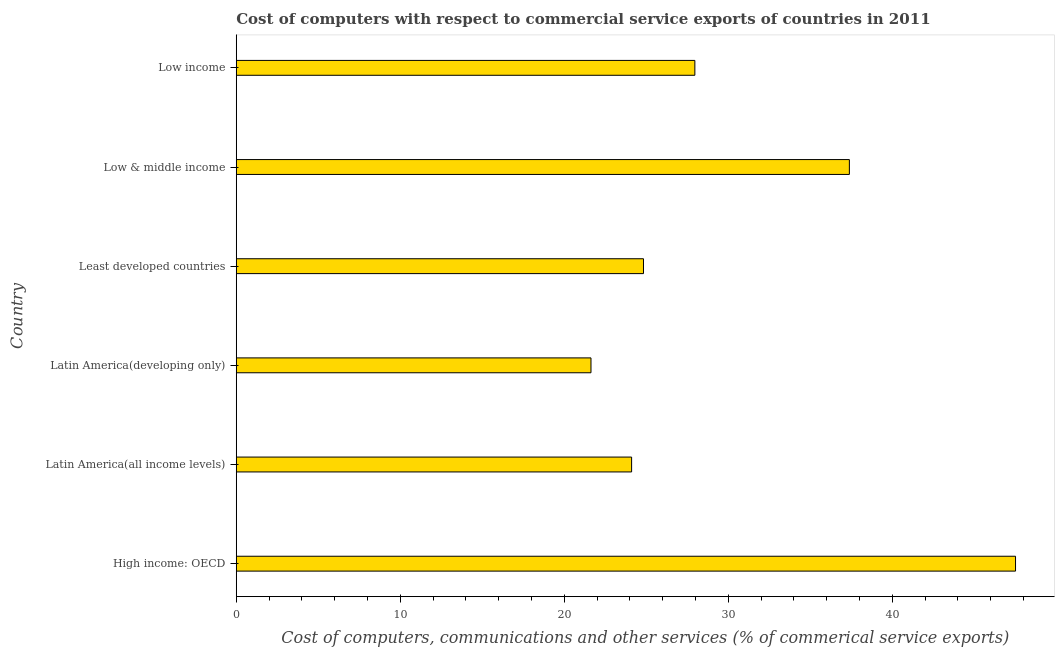What is the title of the graph?
Offer a terse response. Cost of computers with respect to commercial service exports of countries in 2011. What is the label or title of the X-axis?
Provide a short and direct response. Cost of computers, communications and other services (% of commerical service exports). What is the label or title of the Y-axis?
Your response must be concise. Country. What is the  computer and other services in Latin America(developing only)?
Your answer should be compact. 21.63. Across all countries, what is the maximum  computer and other services?
Your response must be concise. 47.51. Across all countries, what is the minimum cost of communications?
Provide a succinct answer. 21.63. In which country was the cost of communications maximum?
Keep it short and to the point. High income: OECD. In which country was the  computer and other services minimum?
Make the answer very short. Latin America(developing only). What is the sum of the  computer and other services?
Provide a short and direct response. 183.4. What is the difference between the  computer and other services in Latin America(all income levels) and Low & middle income?
Ensure brevity in your answer.  -13.28. What is the average  computer and other services per country?
Your response must be concise. 30.57. What is the median cost of communications?
Your answer should be very brief. 26.39. What is the ratio of the  computer and other services in Least developed countries to that in Low income?
Provide a short and direct response. 0.89. What is the difference between the highest and the second highest  computer and other services?
Your answer should be very brief. 10.13. Is the sum of the cost of communications in Latin America(developing only) and Low & middle income greater than the maximum cost of communications across all countries?
Keep it short and to the point. Yes. What is the difference between the highest and the lowest  computer and other services?
Keep it short and to the point. 25.88. Are all the bars in the graph horizontal?
Provide a short and direct response. Yes. Are the values on the major ticks of X-axis written in scientific E-notation?
Ensure brevity in your answer.  No. What is the Cost of computers, communications and other services (% of commerical service exports) in High income: OECD?
Keep it short and to the point. 47.51. What is the Cost of computers, communications and other services (% of commerical service exports) of Latin America(all income levels)?
Your answer should be compact. 24.1. What is the Cost of computers, communications and other services (% of commerical service exports) of Latin America(developing only)?
Keep it short and to the point. 21.63. What is the Cost of computers, communications and other services (% of commerical service exports) in Least developed countries?
Your response must be concise. 24.83. What is the Cost of computers, communications and other services (% of commerical service exports) of Low & middle income?
Keep it short and to the point. 37.38. What is the Cost of computers, communications and other services (% of commerical service exports) in Low income?
Your response must be concise. 27.96. What is the difference between the Cost of computers, communications and other services (% of commerical service exports) in High income: OECD and Latin America(all income levels)?
Your answer should be very brief. 23.41. What is the difference between the Cost of computers, communications and other services (% of commerical service exports) in High income: OECD and Latin America(developing only)?
Make the answer very short. 25.88. What is the difference between the Cost of computers, communications and other services (% of commerical service exports) in High income: OECD and Least developed countries?
Your response must be concise. 22.68. What is the difference between the Cost of computers, communications and other services (% of commerical service exports) in High income: OECD and Low & middle income?
Your response must be concise. 10.13. What is the difference between the Cost of computers, communications and other services (% of commerical service exports) in High income: OECD and Low income?
Make the answer very short. 19.55. What is the difference between the Cost of computers, communications and other services (% of commerical service exports) in Latin America(all income levels) and Latin America(developing only)?
Your answer should be very brief. 2.48. What is the difference between the Cost of computers, communications and other services (% of commerical service exports) in Latin America(all income levels) and Least developed countries?
Give a very brief answer. -0.72. What is the difference between the Cost of computers, communications and other services (% of commerical service exports) in Latin America(all income levels) and Low & middle income?
Offer a terse response. -13.28. What is the difference between the Cost of computers, communications and other services (% of commerical service exports) in Latin America(all income levels) and Low income?
Offer a very short reply. -3.86. What is the difference between the Cost of computers, communications and other services (% of commerical service exports) in Latin America(developing only) and Least developed countries?
Provide a short and direct response. -3.2. What is the difference between the Cost of computers, communications and other services (% of commerical service exports) in Latin America(developing only) and Low & middle income?
Ensure brevity in your answer.  -15.75. What is the difference between the Cost of computers, communications and other services (% of commerical service exports) in Latin America(developing only) and Low income?
Offer a terse response. -6.33. What is the difference between the Cost of computers, communications and other services (% of commerical service exports) in Least developed countries and Low & middle income?
Provide a succinct answer. -12.55. What is the difference between the Cost of computers, communications and other services (% of commerical service exports) in Least developed countries and Low income?
Your answer should be very brief. -3.13. What is the difference between the Cost of computers, communications and other services (% of commerical service exports) in Low & middle income and Low income?
Offer a very short reply. 9.42. What is the ratio of the Cost of computers, communications and other services (% of commerical service exports) in High income: OECD to that in Latin America(all income levels)?
Your answer should be very brief. 1.97. What is the ratio of the Cost of computers, communications and other services (% of commerical service exports) in High income: OECD to that in Latin America(developing only)?
Keep it short and to the point. 2.2. What is the ratio of the Cost of computers, communications and other services (% of commerical service exports) in High income: OECD to that in Least developed countries?
Offer a terse response. 1.91. What is the ratio of the Cost of computers, communications and other services (% of commerical service exports) in High income: OECD to that in Low & middle income?
Provide a succinct answer. 1.27. What is the ratio of the Cost of computers, communications and other services (% of commerical service exports) in High income: OECD to that in Low income?
Your answer should be compact. 1.7. What is the ratio of the Cost of computers, communications and other services (% of commerical service exports) in Latin America(all income levels) to that in Latin America(developing only)?
Offer a terse response. 1.11. What is the ratio of the Cost of computers, communications and other services (% of commerical service exports) in Latin America(all income levels) to that in Low & middle income?
Ensure brevity in your answer.  0.65. What is the ratio of the Cost of computers, communications and other services (% of commerical service exports) in Latin America(all income levels) to that in Low income?
Your response must be concise. 0.86. What is the ratio of the Cost of computers, communications and other services (% of commerical service exports) in Latin America(developing only) to that in Least developed countries?
Make the answer very short. 0.87. What is the ratio of the Cost of computers, communications and other services (% of commerical service exports) in Latin America(developing only) to that in Low & middle income?
Offer a very short reply. 0.58. What is the ratio of the Cost of computers, communications and other services (% of commerical service exports) in Latin America(developing only) to that in Low income?
Provide a short and direct response. 0.77. What is the ratio of the Cost of computers, communications and other services (% of commerical service exports) in Least developed countries to that in Low & middle income?
Provide a short and direct response. 0.66. What is the ratio of the Cost of computers, communications and other services (% of commerical service exports) in Least developed countries to that in Low income?
Offer a terse response. 0.89. What is the ratio of the Cost of computers, communications and other services (% of commerical service exports) in Low & middle income to that in Low income?
Make the answer very short. 1.34. 